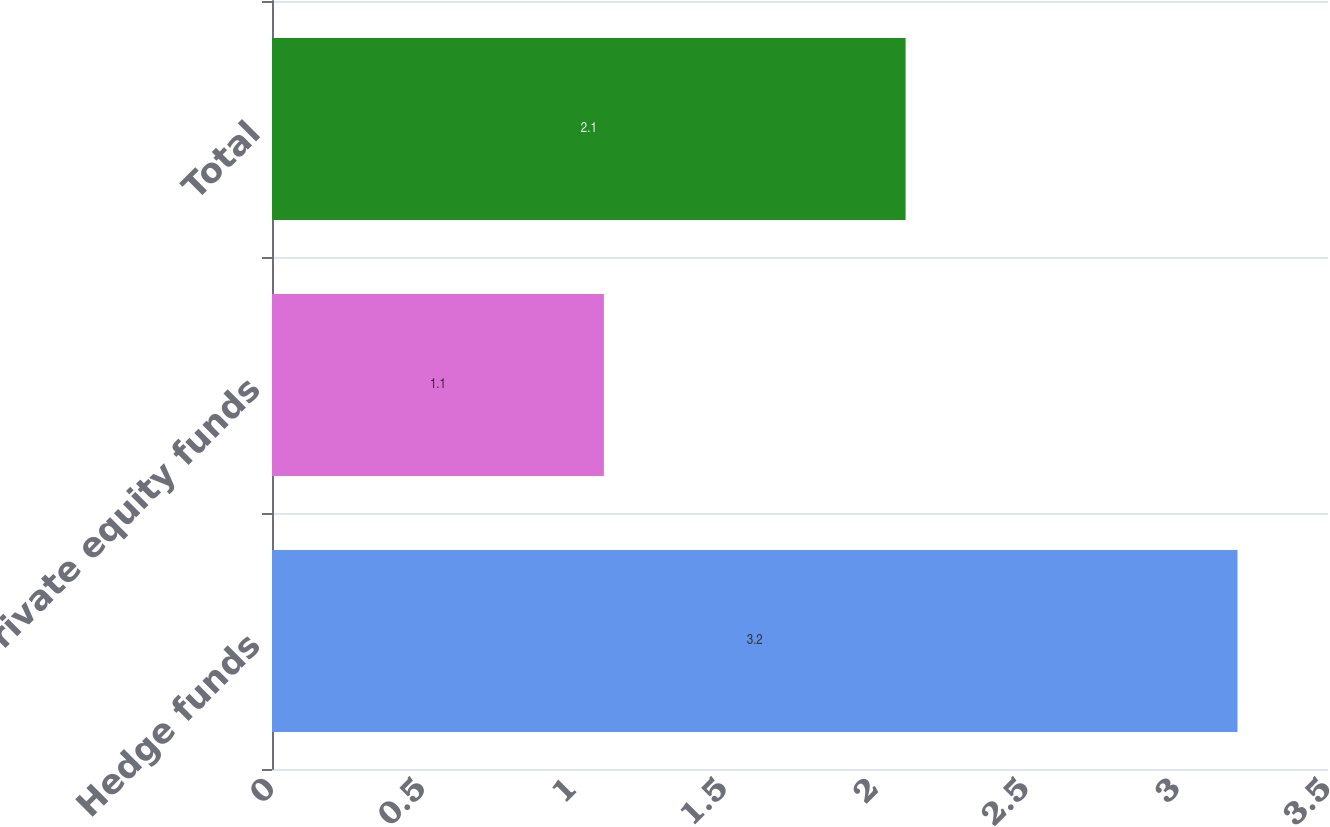<chart> <loc_0><loc_0><loc_500><loc_500><bar_chart><fcel>Hedge funds<fcel>Private equity funds<fcel>Total<nl><fcel>3.2<fcel>1.1<fcel>2.1<nl></chart> 